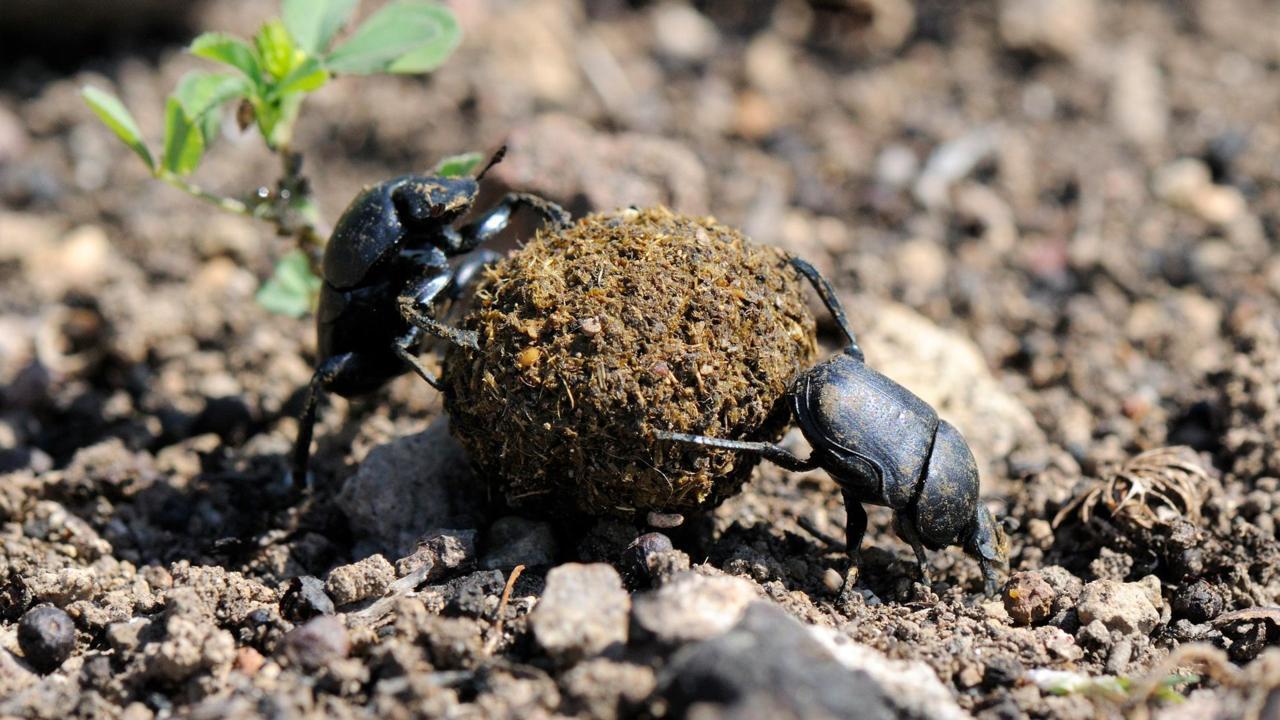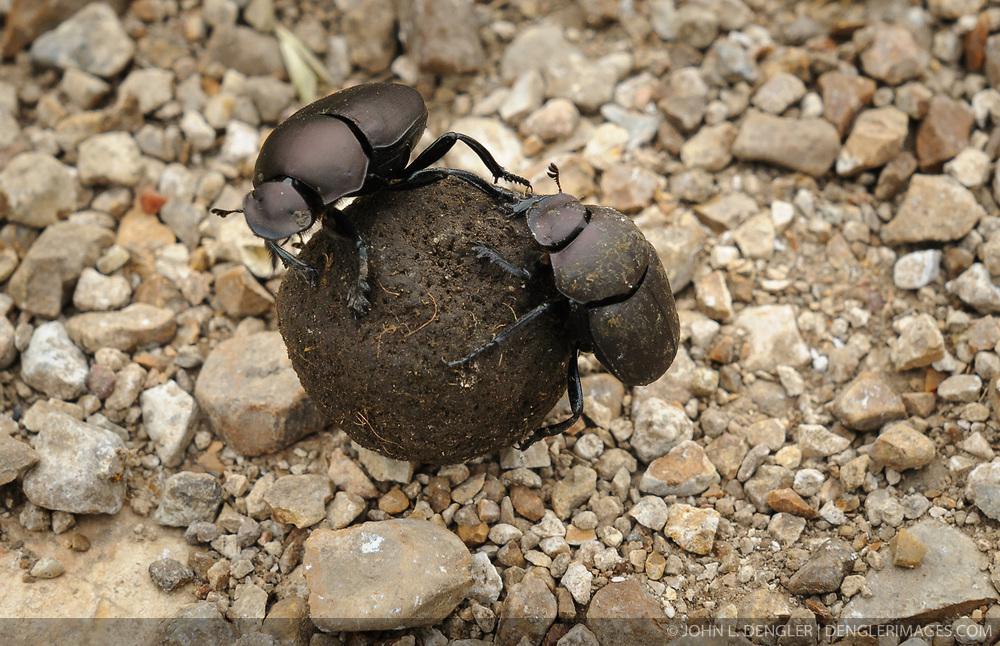The first image is the image on the left, the second image is the image on the right. Evaluate the accuracy of this statement regarding the images: "There is at most three beetles.". Is it true? Answer yes or no. No. The first image is the image on the left, the second image is the image on the right. Examine the images to the left and right. Is the description "In the image on the left, there is no more than one beetle present, industriously building the dung ball." accurate? Answer yes or no. No. 